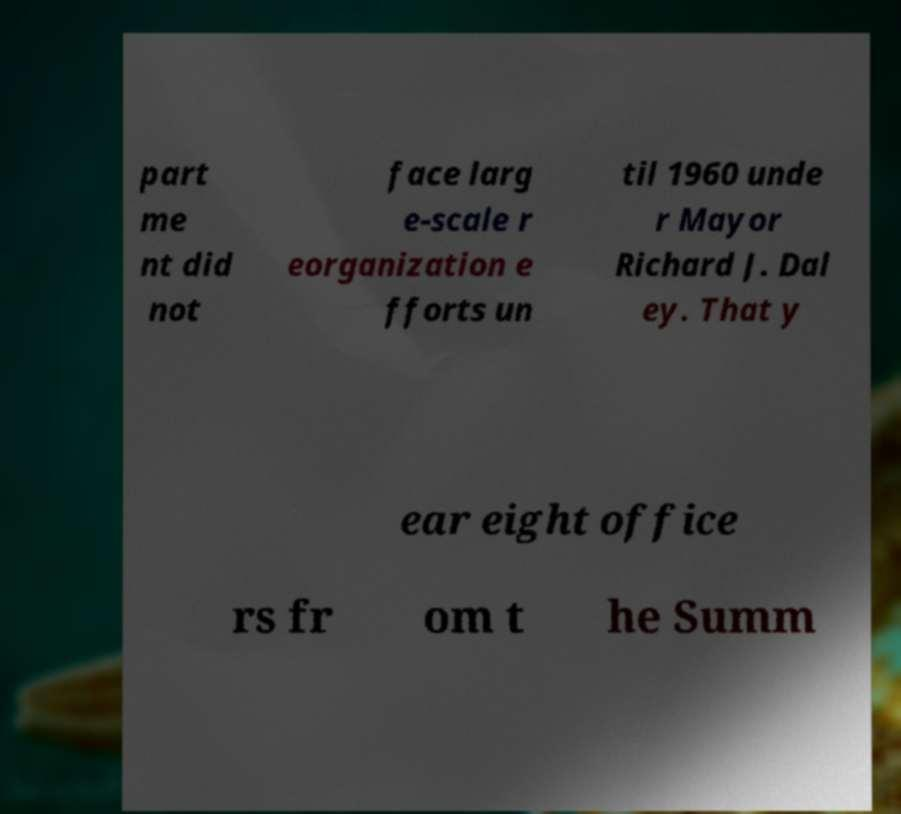Could you extract and type out the text from this image? part me nt did not face larg e-scale r eorganization e fforts un til 1960 unde r Mayor Richard J. Dal ey. That y ear eight office rs fr om t he Summ 